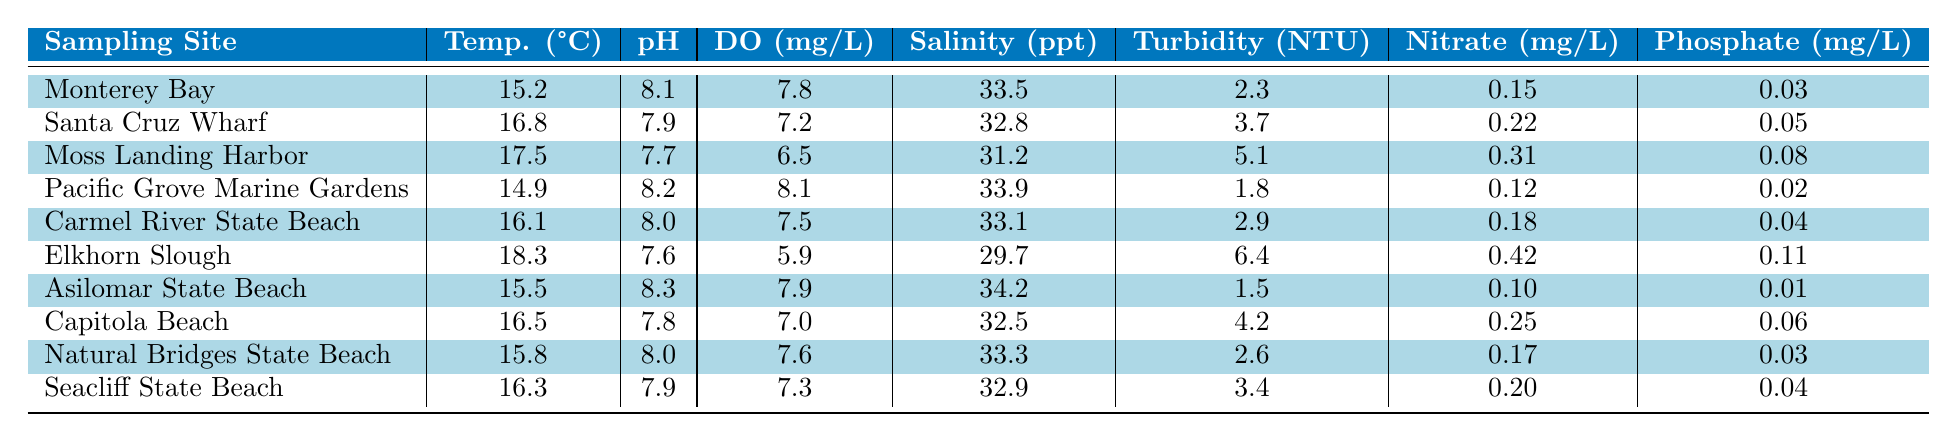What is the temperature at Elkhorn Slough? The table shows that the temperature recorded at Elkhorn Slough is 18.3 °C.
Answer: 18.3 °C Which sampling site has the highest level of nitrate? By reviewing the nitrate levels in the table, Elkhorn Slough has the highest nitrate level at 0.42 mg/L.
Answer: Elkhorn Slough What is the average salinity of the sampled sites? Adding the salinity values: (33.5 + 32.8 + 31.2 + 33.9 + 33.1 + 29.7 + 34.2 + 32.5 + 33.3 + 32.9) =  333.1. There are 10 sites, so the average salinity is 333.1 / 10 = 33.31 ppt.
Answer: 33.31 ppt Is the pH at Natural Bridges State Beach greater than 8.0? The pH value at Natural Bridges State Beach is 8.0, which is not greater than 8.0, so the answer is no.
Answer: No Which site has the lowest dissolved oxygen level? By reviewing the dissolved oxygen levels in the table, Moss Landing Harbor has the lowest level at 6.5 mg/L.
Answer: Moss Landing Harbor If we compare the turbidity at Asilomar State Beach and Seacliff State Beach, which one is clearer? The turbidity at Asilomar State Beach is 1.5 NTU and at Seacliff State Beach is 3.4 NTU. Since lower turbidity indicates clearer water, Asilomar State Beach is clearer.
Answer: Asilomar State Beach What is the difference in turbidity between Elkhorn Slough and Monterey Bay? The turbidity at Elkhorn Slough is 6.4 NTU and at Monterey Bay is 2.3 NTU. The difference is 6.4 - 2.3 = 4.1 NTU, showing Elkhorn Slough is murkier.
Answer: 4.1 NTU Which sampling site has the highest temperature, and what is that temperature? The table reveals that Elkhorn Slough has the highest temperature at 18.3 °C.
Answer: Elkhorn Slough, 18.3 °C If you wanted to find the site with the lowest phosphate level, which one would you choose? Examining the phosphate levels, Asilomar State Beach has the lowest level at 0.01 mg/L.
Answer: Asilomar State Beach Is the water quality (indicated by DO) at Pacific Grove Marine Gardens better than at Elkhorn Slough? Pacific Grove Marine Gardens has a DO level of 8.1 mg/L, whereas Elkhorn Slough has 5.9 mg/L. Since 8.1 is greater than 5.9, the water quality is better at Pacific Grove Marine Gardens.
Answer: Yes 